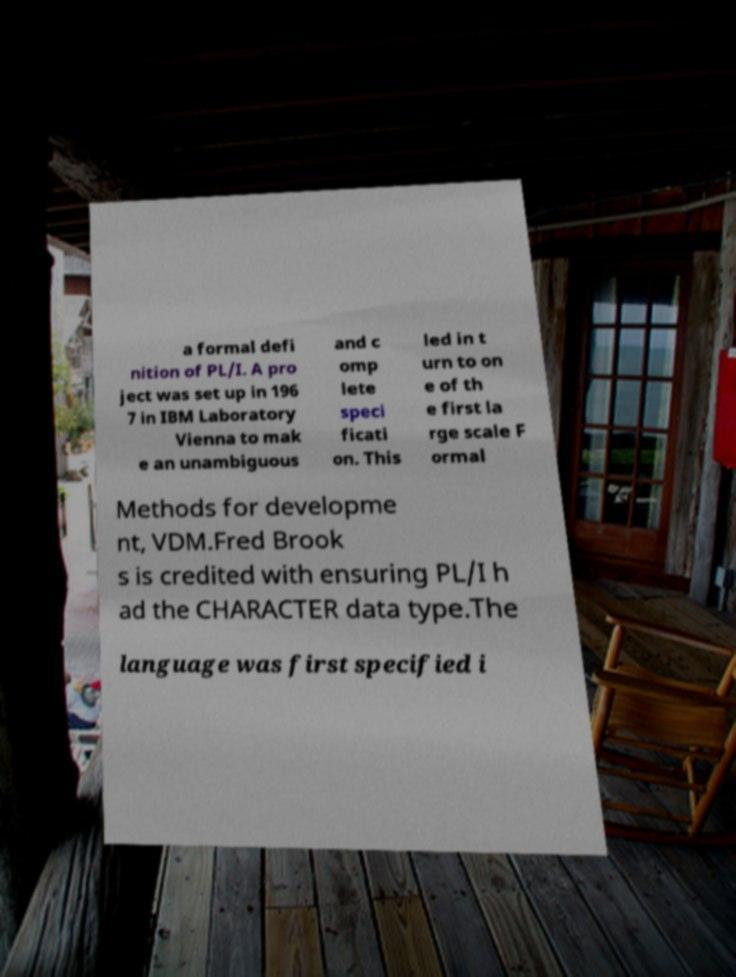Can you accurately transcribe the text from the provided image for me? a formal defi nition of PL/I. A pro ject was set up in 196 7 in IBM Laboratory Vienna to mak e an unambiguous and c omp lete speci ficati on. This led in t urn to on e of th e first la rge scale F ormal Methods for developme nt, VDM.Fred Brook s is credited with ensuring PL/I h ad the CHARACTER data type.The language was first specified i 